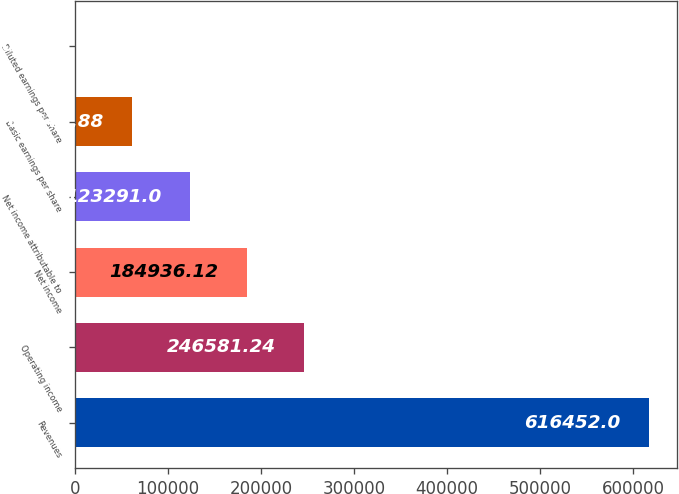Convert chart. <chart><loc_0><loc_0><loc_500><loc_500><bar_chart><fcel>Revenues<fcel>Operating income<fcel>Net income<fcel>Net income attributable to<fcel>Basic earnings per share<fcel>Diluted earnings per share<nl><fcel>616452<fcel>246581<fcel>184936<fcel>123291<fcel>61645.9<fcel>0.76<nl></chart> 